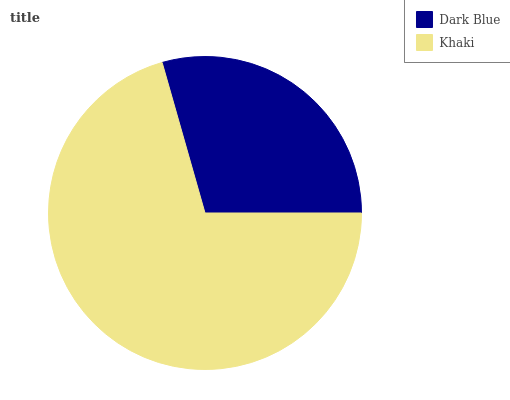Is Dark Blue the minimum?
Answer yes or no. Yes. Is Khaki the maximum?
Answer yes or no. Yes. Is Khaki the minimum?
Answer yes or no. No. Is Khaki greater than Dark Blue?
Answer yes or no. Yes. Is Dark Blue less than Khaki?
Answer yes or no. Yes. Is Dark Blue greater than Khaki?
Answer yes or no. No. Is Khaki less than Dark Blue?
Answer yes or no. No. Is Khaki the high median?
Answer yes or no. Yes. Is Dark Blue the low median?
Answer yes or no. Yes. Is Dark Blue the high median?
Answer yes or no. No. Is Khaki the low median?
Answer yes or no. No. 